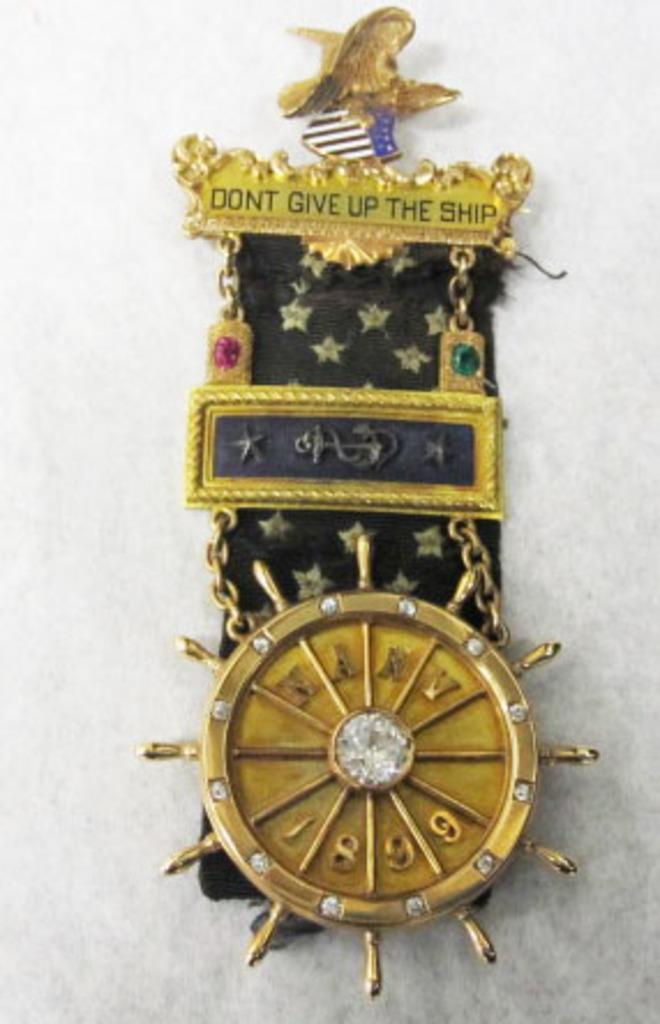<image>
Relay a brief, clear account of the picture shown. A gaudy medal that says Don't give up the ship on the top of it. 